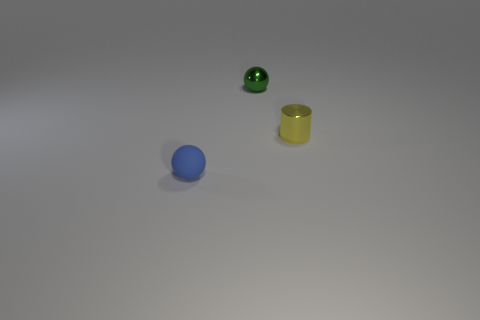Add 3 purple matte balls. How many objects exist? 6 Subtract all cylinders. How many objects are left? 2 Subtract all small metal balls. Subtract all tiny green spheres. How many objects are left? 1 Add 2 tiny blue balls. How many tiny blue balls are left? 3 Add 1 large rubber blocks. How many large rubber blocks exist? 1 Subtract 0 blue cylinders. How many objects are left? 3 